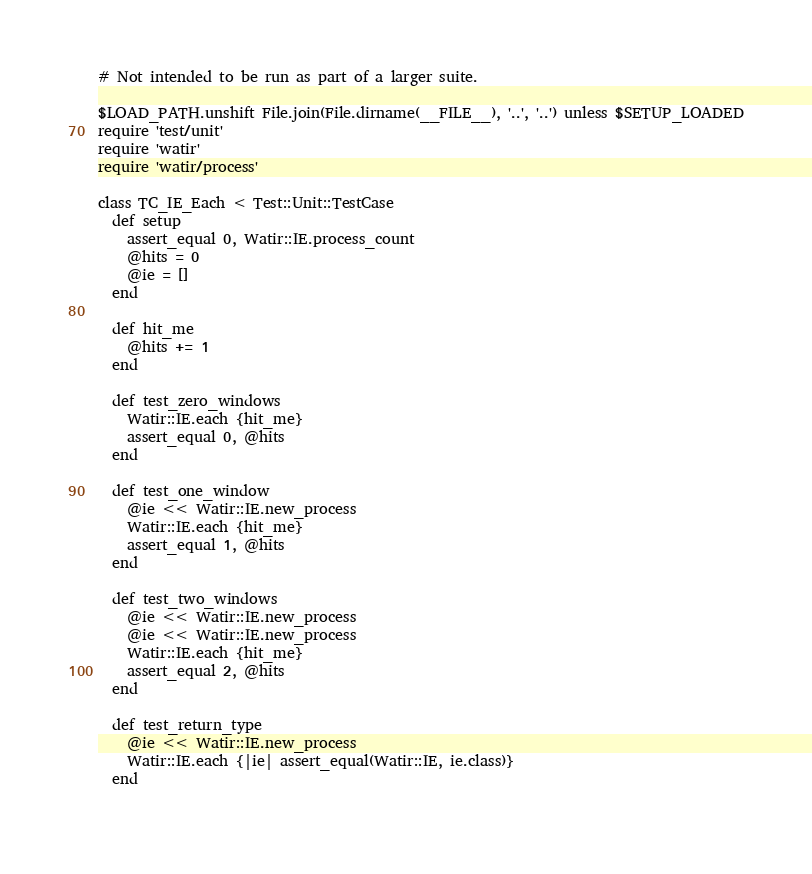<code> <loc_0><loc_0><loc_500><loc_500><_Ruby_># Not intended to be run as part of a larger suite.

$LOAD_PATH.unshift File.join(File.dirname(__FILE__), '..', '..') unless $SETUP_LOADED
require 'test/unit'
require 'watir'
require 'watir/process'

class TC_IE_Each < Test::Unit::TestCase  
  def setup
    assert_equal 0, Watir::IE.process_count
    @hits = 0
    @ie = []
  end
  
  def hit_me
    @hits += 1
  end

  def test_zero_windows
    Watir::IE.each {hit_me}    
    assert_equal 0, @hits
  end
  
  def test_one_window
    @ie << Watir::IE.new_process
    Watir::IE.each {hit_me}    
    assert_equal 1, @hits
  end
  
  def test_two_windows
    @ie << Watir::IE.new_process
    @ie << Watir::IE.new_process
    Watir::IE.each {hit_me}    
    assert_equal 2, @hits
  end
  
  def test_return_type
    @ie << Watir::IE.new_process
    Watir::IE.each {|ie| assert_equal(Watir::IE, ie.class)}    
  end
  </code> 